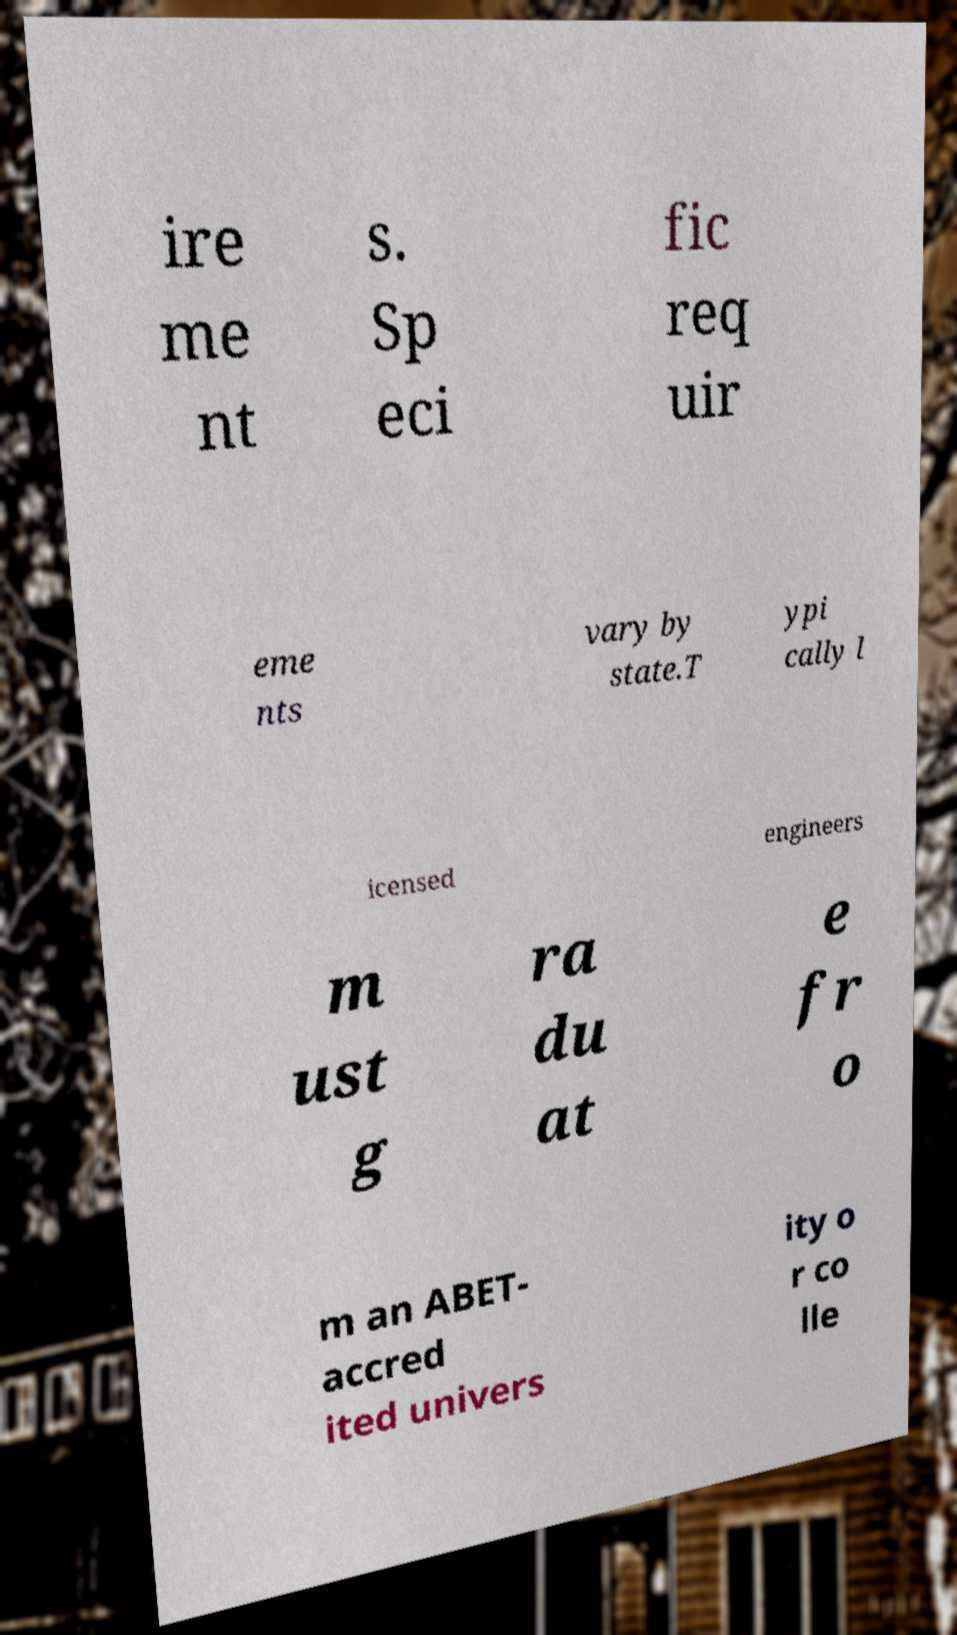Could you assist in decoding the text presented in this image and type it out clearly? ire me nt s. Sp eci fic req uir eme nts vary by state.T ypi cally l icensed engineers m ust g ra du at e fr o m an ABET- accred ited univers ity o r co lle 